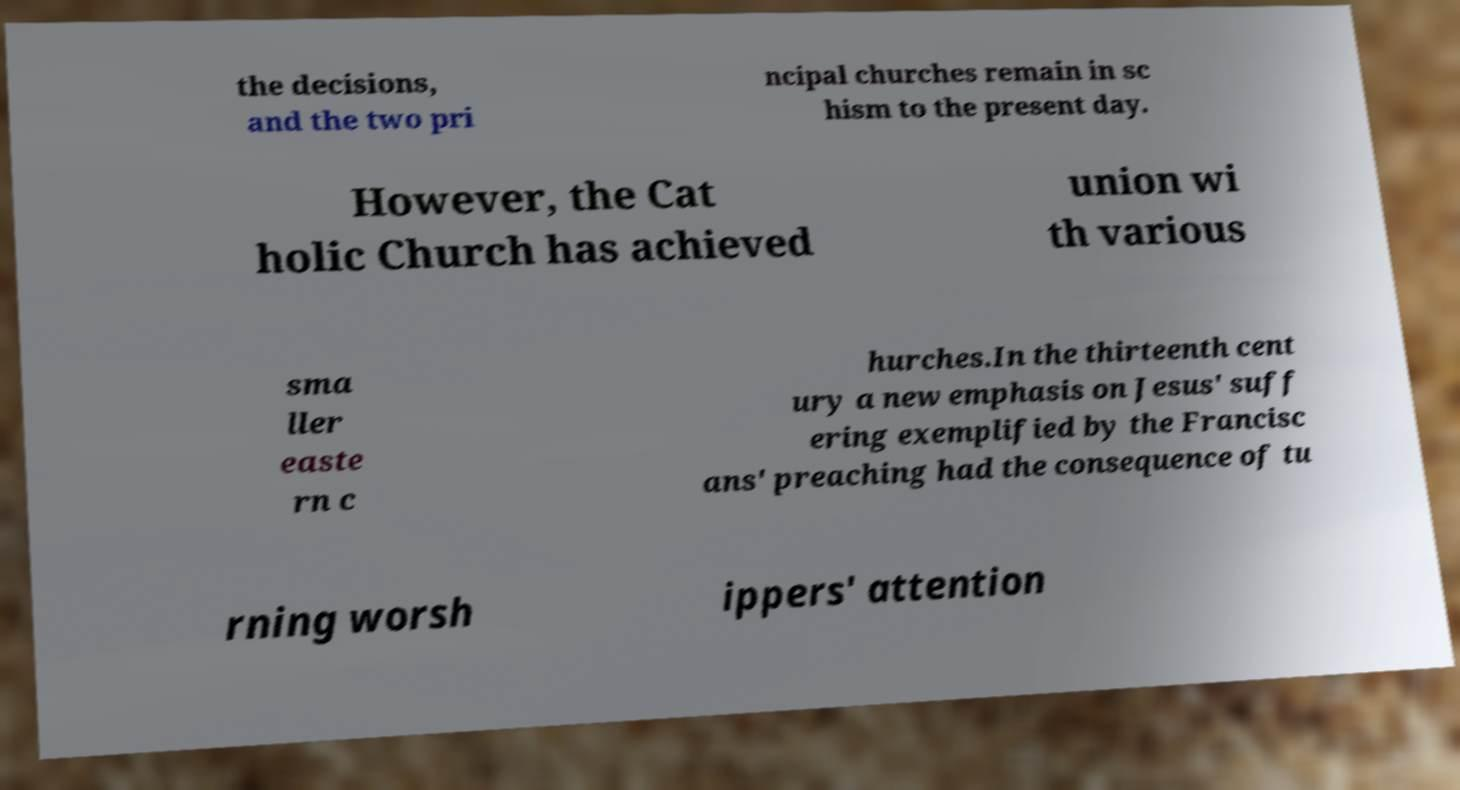Can you read and provide the text displayed in the image?This photo seems to have some interesting text. Can you extract and type it out for me? the decisions, and the two pri ncipal churches remain in sc hism to the present day. However, the Cat holic Church has achieved union wi th various sma ller easte rn c hurches.In the thirteenth cent ury a new emphasis on Jesus' suff ering exemplified by the Francisc ans' preaching had the consequence of tu rning worsh ippers' attention 